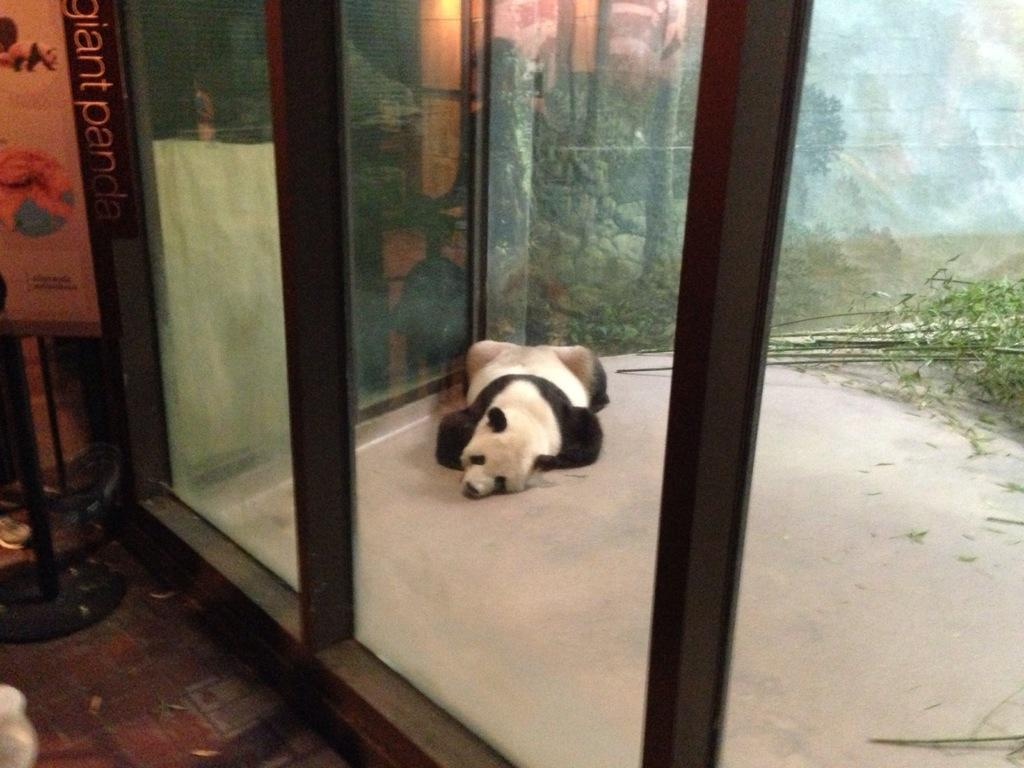What is present in the image? There is an animal in the image. What is the animal doing in the image? The animal is sleeping on the floor. Can you describe the color pattern of the animal? The animal has a white and black color pattern. What can be seen in the background of the image? There are trees in the background of the image, and the trees are green in color. Is there any architectural feature visible in the background? Yes, there is a glass door in the background of the image. How many oranges are hanging from the tree in the image? There are no oranges present in the image; the trees in the background are green and do not have any visible fruit. Is the animal wearing a scarf in the image? There is no indication that the animal is wearing a scarf in the image. 